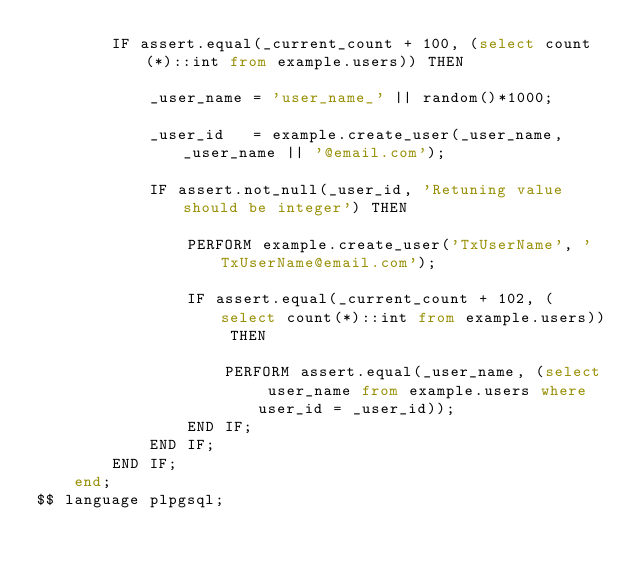Convert code to text. <code><loc_0><loc_0><loc_500><loc_500><_SQL_>        IF assert.equal(_current_count + 100, (select count(*)::int from example.users)) THEN 

            _user_name = 'user_name_' || random()*1000;

            _user_id   = example.create_user(_user_name, _user_name || '@email.com');

            IF assert.not_null(_user_id, 'Retuning value should be integer') THEN

                PERFORM example.create_user('TxUserName', 'TxUserName@email.com');

                IF assert.equal(_current_count + 102, (select count(*)::int from example.users)) THEN 

                    PERFORM assert.equal(_user_name, (select user_name from example.users where user_id = _user_id));
                END IF;
            END IF;
        END IF;
    end;
$$ language plpgsql;
</code> 